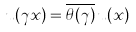Convert formula to latex. <formula><loc_0><loc_0><loc_500><loc_500>u ( \gamma x ) = \overline { \theta ( \gamma ) } \, u ( x )</formula> 